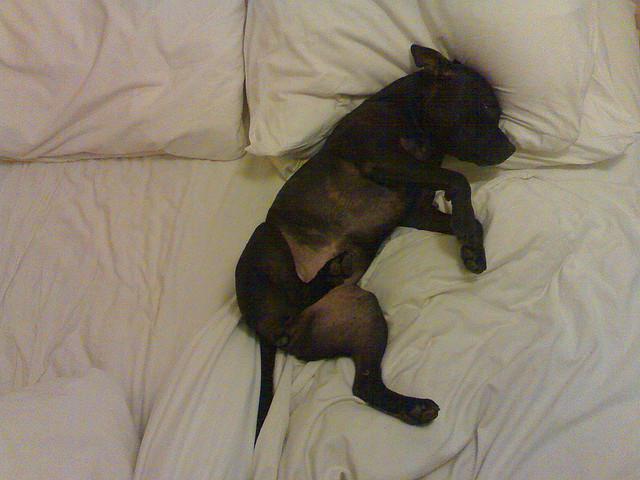How many dogs are there?
Give a very brief answer. 1. 